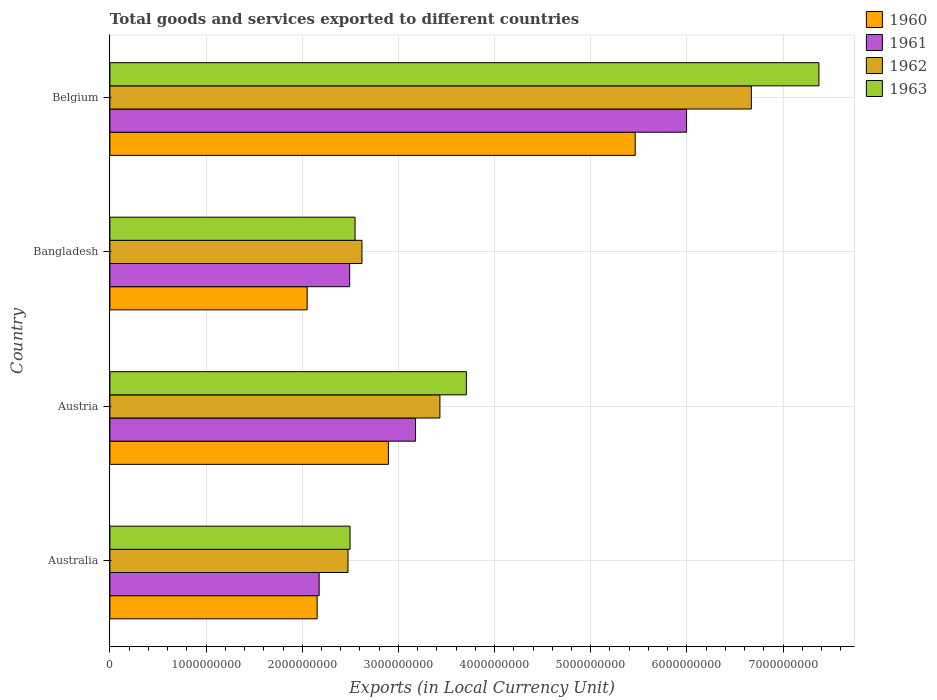How many different coloured bars are there?
Provide a succinct answer. 4. Are the number of bars on each tick of the Y-axis equal?
Your answer should be compact. Yes. How many bars are there on the 3rd tick from the bottom?
Provide a short and direct response. 4. What is the label of the 1st group of bars from the top?
Keep it short and to the point. Belgium. What is the Amount of goods and services exports in 1962 in Australia?
Make the answer very short. 2.48e+09. Across all countries, what is the maximum Amount of goods and services exports in 1963?
Provide a succinct answer. 7.37e+09. Across all countries, what is the minimum Amount of goods and services exports in 1963?
Give a very brief answer. 2.50e+09. In which country was the Amount of goods and services exports in 1961 maximum?
Give a very brief answer. Belgium. What is the total Amount of goods and services exports in 1963 in the graph?
Make the answer very short. 1.61e+1. What is the difference between the Amount of goods and services exports in 1963 in Australia and that in Austria?
Your answer should be compact. -1.21e+09. What is the difference between the Amount of goods and services exports in 1963 in Australia and the Amount of goods and services exports in 1960 in Austria?
Provide a succinct answer. -3.99e+08. What is the average Amount of goods and services exports in 1960 per country?
Make the answer very short. 3.14e+09. What is the difference between the Amount of goods and services exports in 1960 and Amount of goods and services exports in 1963 in Austria?
Your response must be concise. -8.11e+08. What is the ratio of the Amount of goods and services exports in 1962 in Australia to that in Belgium?
Ensure brevity in your answer.  0.37. Is the Amount of goods and services exports in 1960 in Australia less than that in Belgium?
Provide a short and direct response. Yes. What is the difference between the highest and the second highest Amount of goods and services exports in 1961?
Your response must be concise. 2.82e+09. What is the difference between the highest and the lowest Amount of goods and services exports in 1961?
Provide a short and direct response. 3.82e+09. Is the sum of the Amount of goods and services exports in 1962 in Austria and Belgium greater than the maximum Amount of goods and services exports in 1963 across all countries?
Your answer should be compact. Yes. Is it the case that in every country, the sum of the Amount of goods and services exports in 1963 and Amount of goods and services exports in 1961 is greater than the sum of Amount of goods and services exports in 1960 and Amount of goods and services exports in 1962?
Your answer should be compact. No. What does the 2nd bar from the top in Australia represents?
Offer a very short reply. 1962. What does the 4th bar from the bottom in Australia represents?
Your response must be concise. 1963. Is it the case that in every country, the sum of the Amount of goods and services exports in 1961 and Amount of goods and services exports in 1963 is greater than the Amount of goods and services exports in 1960?
Your answer should be very brief. Yes. How many countries are there in the graph?
Make the answer very short. 4. What is the difference between two consecutive major ticks on the X-axis?
Ensure brevity in your answer.  1.00e+09. Does the graph contain grids?
Give a very brief answer. Yes. What is the title of the graph?
Your response must be concise. Total goods and services exported to different countries. Does "2006" appear as one of the legend labels in the graph?
Your response must be concise. No. What is the label or title of the X-axis?
Offer a terse response. Exports (in Local Currency Unit). What is the Exports (in Local Currency Unit) of 1960 in Australia?
Your answer should be very brief. 2.16e+09. What is the Exports (in Local Currency Unit) in 1961 in Australia?
Offer a terse response. 2.18e+09. What is the Exports (in Local Currency Unit) of 1962 in Australia?
Make the answer very short. 2.48e+09. What is the Exports (in Local Currency Unit) of 1963 in Australia?
Provide a succinct answer. 2.50e+09. What is the Exports (in Local Currency Unit) in 1960 in Austria?
Give a very brief answer. 2.90e+09. What is the Exports (in Local Currency Unit) in 1961 in Austria?
Offer a very short reply. 3.18e+09. What is the Exports (in Local Currency Unit) of 1962 in Austria?
Your answer should be very brief. 3.43e+09. What is the Exports (in Local Currency Unit) of 1963 in Austria?
Give a very brief answer. 3.71e+09. What is the Exports (in Local Currency Unit) of 1960 in Bangladesh?
Your answer should be very brief. 2.05e+09. What is the Exports (in Local Currency Unit) of 1961 in Bangladesh?
Make the answer very short. 2.49e+09. What is the Exports (in Local Currency Unit) in 1962 in Bangladesh?
Your answer should be compact. 2.62e+09. What is the Exports (in Local Currency Unit) of 1963 in Bangladesh?
Your answer should be compact. 2.55e+09. What is the Exports (in Local Currency Unit) in 1960 in Belgium?
Make the answer very short. 5.46e+09. What is the Exports (in Local Currency Unit) of 1961 in Belgium?
Make the answer very short. 6.00e+09. What is the Exports (in Local Currency Unit) of 1962 in Belgium?
Make the answer very short. 6.67e+09. What is the Exports (in Local Currency Unit) in 1963 in Belgium?
Offer a very short reply. 7.37e+09. Across all countries, what is the maximum Exports (in Local Currency Unit) in 1960?
Offer a terse response. 5.46e+09. Across all countries, what is the maximum Exports (in Local Currency Unit) in 1961?
Ensure brevity in your answer.  6.00e+09. Across all countries, what is the maximum Exports (in Local Currency Unit) in 1962?
Ensure brevity in your answer.  6.67e+09. Across all countries, what is the maximum Exports (in Local Currency Unit) of 1963?
Keep it short and to the point. 7.37e+09. Across all countries, what is the minimum Exports (in Local Currency Unit) of 1960?
Offer a very short reply. 2.05e+09. Across all countries, what is the minimum Exports (in Local Currency Unit) of 1961?
Ensure brevity in your answer.  2.18e+09. Across all countries, what is the minimum Exports (in Local Currency Unit) in 1962?
Offer a terse response. 2.48e+09. Across all countries, what is the minimum Exports (in Local Currency Unit) in 1963?
Provide a succinct answer. 2.50e+09. What is the total Exports (in Local Currency Unit) in 1960 in the graph?
Your answer should be very brief. 1.26e+1. What is the total Exports (in Local Currency Unit) of 1961 in the graph?
Your answer should be very brief. 1.38e+1. What is the total Exports (in Local Currency Unit) of 1962 in the graph?
Offer a very short reply. 1.52e+1. What is the total Exports (in Local Currency Unit) in 1963 in the graph?
Provide a succinct answer. 1.61e+1. What is the difference between the Exports (in Local Currency Unit) in 1960 in Australia and that in Austria?
Offer a terse response. -7.41e+08. What is the difference between the Exports (in Local Currency Unit) in 1961 in Australia and that in Austria?
Offer a terse response. -1.00e+09. What is the difference between the Exports (in Local Currency Unit) of 1962 in Australia and that in Austria?
Give a very brief answer. -9.56e+08. What is the difference between the Exports (in Local Currency Unit) of 1963 in Australia and that in Austria?
Offer a very short reply. -1.21e+09. What is the difference between the Exports (in Local Currency Unit) in 1960 in Australia and that in Bangladesh?
Ensure brevity in your answer.  1.04e+08. What is the difference between the Exports (in Local Currency Unit) of 1961 in Australia and that in Bangladesh?
Offer a terse response. -3.17e+08. What is the difference between the Exports (in Local Currency Unit) of 1962 in Australia and that in Bangladesh?
Make the answer very short. -1.45e+08. What is the difference between the Exports (in Local Currency Unit) in 1963 in Australia and that in Bangladesh?
Provide a short and direct response. -5.21e+07. What is the difference between the Exports (in Local Currency Unit) of 1960 in Australia and that in Belgium?
Give a very brief answer. -3.31e+09. What is the difference between the Exports (in Local Currency Unit) of 1961 in Australia and that in Belgium?
Give a very brief answer. -3.82e+09. What is the difference between the Exports (in Local Currency Unit) in 1962 in Australia and that in Belgium?
Your response must be concise. -4.19e+09. What is the difference between the Exports (in Local Currency Unit) in 1963 in Australia and that in Belgium?
Keep it short and to the point. -4.88e+09. What is the difference between the Exports (in Local Currency Unit) in 1960 in Austria and that in Bangladesh?
Offer a terse response. 8.45e+08. What is the difference between the Exports (in Local Currency Unit) of 1961 in Austria and that in Bangladesh?
Ensure brevity in your answer.  6.85e+08. What is the difference between the Exports (in Local Currency Unit) of 1962 in Austria and that in Bangladesh?
Provide a succinct answer. 8.10e+08. What is the difference between the Exports (in Local Currency Unit) of 1963 in Austria and that in Bangladesh?
Offer a very short reply. 1.16e+09. What is the difference between the Exports (in Local Currency Unit) in 1960 in Austria and that in Belgium?
Offer a very short reply. -2.57e+09. What is the difference between the Exports (in Local Currency Unit) in 1961 in Austria and that in Belgium?
Offer a very short reply. -2.82e+09. What is the difference between the Exports (in Local Currency Unit) in 1962 in Austria and that in Belgium?
Your answer should be very brief. -3.24e+09. What is the difference between the Exports (in Local Currency Unit) in 1963 in Austria and that in Belgium?
Your answer should be compact. -3.67e+09. What is the difference between the Exports (in Local Currency Unit) in 1960 in Bangladesh and that in Belgium?
Give a very brief answer. -3.41e+09. What is the difference between the Exports (in Local Currency Unit) of 1961 in Bangladesh and that in Belgium?
Your answer should be very brief. -3.50e+09. What is the difference between the Exports (in Local Currency Unit) in 1962 in Bangladesh and that in Belgium?
Give a very brief answer. -4.05e+09. What is the difference between the Exports (in Local Currency Unit) of 1963 in Bangladesh and that in Belgium?
Provide a succinct answer. -4.82e+09. What is the difference between the Exports (in Local Currency Unit) of 1960 in Australia and the Exports (in Local Currency Unit) of 1961 in Austria?
Your answer should be compact. -1.02e+09. What is the difference between the Exports (in Local Currency Unit) in 1960 in Australia and the Exports (in Local Currency Unit) in 1962 in Austria?
Offer a terse response. -1.28e+09. What is the difference between the Exports (in Local Currency Unit) in 1960 in Australia and the Exports (in Local Currency Unit) in 1963 in Austria?
Give a very brief answer. -1.55e+09. What is the difference between the Exports (in Local Currency Unit) in 1961 in Australia and the Exports (in Local Currency Unit) in 1962 in Austria?
Your answer should be compact. -1.26e+09. What is the difference between the Exports (in Local Currency Unit) in 1961 in Australia and the Exports (in Local Currency Unit) in 1963 in Austria?
Provide a succinct answer. -1.53e+09. What is the difference between the Exports (in Local Currency Unit) of 1962 in Australia and the Exports (in Local Currency Unit) of 1963 in Austria?
Keep it short and to the point. -1.23e+09. What is the difference between the Exports (in Local Currency Unit) in 1960 in Australia and the Exports (in Local Currency Unit) in 1961 in Bangladesh?
Ensure brevity in your answer.  -3.38e+08. What is the difference between the Exports (in Local Currency Unit) of 1960 in Australia and the Exports (in Local Currency Unit) of 1962 in Bangladesh?
Your answer should be very brief. -4.66e+08. What is the difference between the Exports (in Local Currency Unit) of 1960 in Australia and the Exports (in Local Currency Unit) of 1963 in Bangladesh?
Ensure brevity in your answer.  -3.94e+08. What is the difference between the Exports (in Local Currency Unit) in 1961 in Australia and the Exports (in Local Currency Unit) in 1962 in Bangladesh?
Keep it short and to the point. -4.45e+08. What is the difference between the Exports (in Local Currency Unit) in 1961 in Australia and the Exports (in Local Currency Unit) in 1963 in Bangladesh?
Give a very brief answer. -3.73e+08. What is the difference between the Exports (in Local Currency Unit) in 1962 in Australia and the Exports (in Local Currency Unit) in 1963 in Bangladesh?
Make the answer very short. -7.31e+07. What is the difference between the Exports (in Local Currency Unit) of 1960 in Australia and the Exports (in Local Currency Unit) of 1961 in Belgium?
Offer a terse response. -3.84e+09. What is the difference between the Exports (in Local Currency Unit) of 1960 in Australia and the Exports (in Local Currency Unit) of 1962 in Belgium?
Ensure brevity in your answer.  -4.52e+09. What is the difference between the Exports (in Local Currency Unit) in 1960 in Australia and the Exports (in Local Currency Unit) in 1963 in Belgium?
Offer a terse response. -5.22e+09. What is the difference between the Exports (in Local Currency Unit) in 1961 in Australia and the Exports (in Local Currency Unit) in 1962 in Belgium?
Your answer should be compact. -4.49e+09. What is the difference between the Exports (in Local Currency Unit) of 1961 in Australia and the Exports (in Local Currency Unit) of 1963 in Belgium?
Make the answer very short. -5.20e+09. What is the difference between the Exports (in Local Currency Unit) of 1962 in Australia and the Exports (in Local Currency Unit) of 1963 in Belgium?
Make the answer very short. -4.90e+09. What is the difference between the Exports (in Local Currency Unit) in 1960 in Austria and the Exports (in Local Currency Unit) in 1961 in Bangladesh?
Your response must be concise. 4.03e+08. What is the difference between the Exports (in Local Currency Unit) in 1960 in Austria and the Exports (in Local Currency Unit) in 1962 in Bangladesh?
Offer a very short reply. 2.75e+08. What is the difference between the Exports (in Local Currency Unit) of 1960 in Austria and the Exports (in Local Currency Unit) of 1963 in Bangladesh?
Offer a terse response. 3.47e+08. What is the difference between the Exports (in Local Currency Unit) of 1961 in Austria and the Exports (in Local Currency Unit) of 1962 in Bangladesh?
Provide a succinct answer. 5.57e+08. What is the difference between the Exports (in Local Currency Unit) of 1961 in Austria and the Exports (in Local Currency Unit) of 1963 in Bangladesh?
Give a very brief answer. 6.29e+08. What is the difference between the Exports (in Local Currency Unit) in 1962 in Austria and the Exports (in Local Currency Unit) in 1963 in Bangladesh?
Offer a terse response. 8.83e+08. What is the difference between the Exports (in Local Currency Unit) in 1960 in Austria and the Exports (in Local Currency Unit) in 1961 in Belgium?
Provide a short and direct response. -3.10e+09. What is the difference between the Exports (in Local Currency Unit) in 1960 in Austria and the Exports (in Local Currency Unit) in 1962 in Belgium?
Your answer should be compact. -3.77e+09. What is the difference between the Exports (in Local Currency Unit) in 1960 in Austria and the Exports (in Local Currency Unit) in 1963 in Belgium?
Give a very brief answer. -4.48e+09. What is the difference between the Exports (in Local Currency Unit) of 1961 in Austria and the Exports (in Local Currency Unit) of 1962 in Belgium?
Offer a very short reply. -3.49e+09. What is the difference between the Exports (in Local Currency Unit) of 1961 in Austria and the Exports (in Local Currency Unit) of 1963 in Belgium?
Offer a terse response. -4.19e+09. What is the difference between the Exports (in Local Currency Unit) in 1962 in Austria and the Exports (in Local Currency Unit) in 1963 in Belgium?
Keep it short and to the point. -3.94e+09. What is the difference between the Exports (in Local Currency Unit) in 1960 in Bangladesh and the Exports (in Local Currency Unit) in 1961 in Belgium?
Offer a very short reply. -3.94e+09. What is the difference between the Exports (in Local Currency Unit) in 1960 in Bangladesh and the Exports (in Local Currency Unit) in 1962 in Belgium?
Give a very brief answer. -4.62e+09. What is the difference between the Exports (in Local Currency Unit) in 1960 in Bangladesh and the Exports (in Local Currency Unit) in 1963 in Belgium?
Give a very brief answer. -5.32e+09. What is the difference between the Exports (in Local Currency Unit) of 1961 in Bangladesh and the Exports (in Local Currency Unit) of 1962 in Belgium?
Provide a short and direct response. -4.18e+09. What is the difference between the Exports (in Local Currency Unit) of 1961 in Bangladesh and the Exports (in Local Currency Unit) of 1963 in Belgium?
Your answer should be very brief. -4.88e+09. What is the difference between the Exports (in Local Currency Unit) of 1962 in Bangladesh and the Exports (in Local Currency Unit) of 1963 in Belgium?
Make the answer very short. -4.75e+09. What is the average Exports (in Local Currency Unit) of 1960 per country?
Offer a very short reply. 3.14e+09. What is the average Exports (in Local Currency Unit) of 1961 per country?
Keep it short and to the point. 3.46e+09. What is the average Exports (in Local Currency Unit) in 1962 per country?
Give a very brief answer. 3.80e+09. What is the average Exports (in Local Currency Unit) in 1963 per country?
Your answer should be very brief. 4.03e+09. What is the difference between the Exports (in Local Currency Unit) in 1960 and Exports (in Local Currency Unit) in 1961 in Australia?
Your answer should be very brief. -2.10e+07. What is the difference between the Exports (in Local Currency Unit) in 1960 and Exports (in Local Currency Unit) in 1962 in Australia?
Your answer should be very brief. -3.21e+08. What is the difference between the Exports (in Local Currency Unit) of 1960 and Exports (in Local Currency Unit) of 1963 in Australia?
Provide a short and direct response. -3.42e+08. What is the difference between the Exports (in Local Currency Unit) in 1961 and Exports (in Local Currency Unit) in 1962 in Australia?
Provide a succinct answer. -3.00e+08. What is the difference between the Exports (in Local Currency Unit) of 1961 and Exports (in Local Currency Unit) of 1963 in Australia?
Keep it short and to the point. -3.21e+08. What is the difference between the Exports (in Local Currency Unit) in 1962 and Exports (in Local Currency Unit) in 1963 in Australia?
Offer a terse response. -2.10e+07. What is the difference between the Exports (in Local Currency Unit) in 1960 and Exports (in Local Currency Unit) in 1961 in Austria?
Give a very brief answer. -2.82e+08. What is the difference between the Exports (in Local Currency Unit) in 1960 and Exports (in Local Currency Unit) in 1962 in Austria?
Offer a terse response. -5.36e+08. What is the difference between the Exports (in Local Currency Unit) of 1960 and Exports (in Local Currency Unit) of 1963 in Austria?
Give a very brief answer. -8.11e+08. What is the difference between the Exports (in Local Currency Unit) in 1961 and Exports (in Local Currency Unit) in 1962 in Austria?
Your answer should be compact. -2.53e+08. What is the difference between the Exports (in Local Currency Unit) in 1961 and Exports (in Local Currency Unit) in 1963 in Austria?
Offer a terse response. -5.29e+08. What is the difference between the Exports (in Local Currency Unit) of 1962 and Exports (in Local Currency Unit) of 1963 in Austria?
Give a very brief answer. -2.75e+08. What is the difference between the Exports (in Local Currency Unit) of 1960 and Exports (in Local Currency Unit) of 1961 in Bangladesh?
Your answer should be very brief. -4.42e+08. What is the difference between the Exports (in Local Currency Unit) of 1960 and Exports (in Local Currency Unit) of 1962 in Bangladesh?
Offer a terse response. -5.70e+08. What is the difference between the Exports (in Local Currency Unit) in 1960 and Exports (in Local Currency Unit) in 1963 in Bangladesh?
Your answer should be very brief. -4.98e+08. What is the difference between the Exports (in Local Currency Unit) in 1961 and Exports (in Local Currency Unit) in 1962 in Bangladesh?
Provide a short and direct response. -1.28e+08. What is the difference between the Exports (in Local Currency Unit) in 1961 and Exports (in Local Currency Unit) in 1963 in Bangladesh?
Offer a very short reply. -5.58e+07. What is the difference between the Exports (in Local Currency Unit) in 1962 and Exports (in Local Currency Unit) in 1963 in Bangladesh?
Your answer should be very brief. 7.21e+07. What is the difference between the Exports (in Local Currency Unit) of 1960 and Exports (in Local Currency Unit) of 1961 in Belgium?
Your response must be concise. -5.34e+08. What is the difference between the Exports (in Local Currency Unit) in 1960 and Exports (in Local Currency Unit) in 1962 in Belgium?
Offer a very short reply. -1.21e+09. What is the difference between the Exports (in Local Currency Unit) of 1960 and Exports (in Local Currency Unit) of 1963 in Belgium?
Provide a succinct answer. -1.91e+09. What is the difference between the Exports (in Local Currency Unit) of 1961 and Exports (in Local Currency Unit) of 1962 in Belgium?
Your answer should be compact. -6.74e+08. What is the difference between the Exports (in Local Currency Unit) in 1961 and Exports (in Local Currency Unit) in 1963 in Belgium?
Your response must be concise. -1.38e+09. What is the difference between the Exports (in Local Currency Unit) in 1962 and Exports (in Local Currency Unit) in 1963 in Belgium?
Provide a short and direct response. -7.02e+08. What is the ratio of the Exports (in Local Currency Unit) in 1960 in Australia to that in Austria?
Give a very brief answer. 0.74. What is the ratio of the Exports (in Local Currency Unit) of 1961 in Australia to that in Austria?
Your answer should be very brief. 0.68. What is the ratio of the Exports (in Local Currency Unit) of 1962 in Australia to that in Austria?
Offer a very short reply. 0.72. What is the ratio of the Exports (in Local Currency Unit) in 1963 in Australia to that in Austria?
Make the answer very short. 0.67. What is the ratio of the Exports (in Local Currency Unit) in 1960 in Australia to that in Bangladesh?
Offer a very short reply. 1.05. What is the ratio of the Exports (in Local Currency Unit) in 1961 in Australia to that in Bangladesh?
Ensure brevity in your answer.  0.87. What is the ratio of the Exports (in Local Currency Unit) of 1962 in Australia to that in Bangladesh?
Provide a short and direct response. 0.94. What is the ratio of the Exports (in Local Currency Unit) in 1963 in Australia to that in Bangladesh?
Your answer should be very brief. 0.98. What is the ratio of the Exports (in Local Currency Unit) in 1960 in Australia to that in Belgium?
Make the answer very short. 0.39. What is the ratio of the Exports (in Local Currency Unit) in 1961 in Australia to that in Belgium?
Your answer should be very brief. 0.36. What is the ratio of the Exports (in Local Currency Unit) in 1962 in Australia to that in Belgium?
Make the answer very short. 0.37. What is the ratio of the Exports (in Local Currency Unit) in 1963 in Australia to that in Belgium?
Your answer should be compact. 0.34. What is the ratio of the Exports (in Local Currency Unit) of 1960 in Austria to that in Bangladesh?
Your response must be concise. 1.41. What is the ratio of the Exports (in Local Currency Unit) in 1961 in Austria to that in Bangladesh?
Make the answer very short. 1.27. What is the ratio of the Exports (in Local Currency Unit) of 1962 in Austria to that in Bangladesh?
Provide a succinct answer. 1.31. What is the ratio of the Exports (in Local Currency Unit) of 1963 in Austria to that in Bangladesh?
Your answer should be compact. 1.45. What is the ratio of the Exports (in Local Currency Unit) of 1960 in Austria to that in Belgium?
Keep it short and to the point. 0.53. What is the ratio of the Exports (in Local Currency Unit) in 1961 in Austria to that in Belgium?
Offer a very short reply. 0.53. What is the ratio of the Exports (in Local Currency Unit) of 1962 in Austria to that in Belgium?
Provide a short and direct response. 0.51. What is the ratio of the Exports (in Local Currency Unit) of 1963 in Austria to that in Belgium?
Ensure brevity in your answer.  0.5. What is the ratio of the Exports (in Local Currency Unit) of 1960 in Bangladesh to that in Belgium?
Ensure brevity in your answer.  0.38. What is the ratio of the Exports (in Local Currency Unit) in 1961 in Bangladesh to that in Belgium?
Provide a short and direct response. 0.42. What is the ratio of the Exports (in Local Currency Unit) of 1962 in Bangladesh to that in Belgium?
Give a very brief answer. 0.39. What is the ratio of the Exports (in Local Currency Unit) in 1963 in Bangladesh to that in Belgium?
Make the answer very short. 0.35. What is the difference between the highest and the second highest Exports (in Local Currency Unit) of 1960?
Provide a short and direct response. 2.57e+09. What is the difference between the highest and the second highest Exports (in Local Currency Unit) of 1961?
Give a very brief answer. 2.82e+09. What is the difference between the highest and the second highest Exports (in Local Currency Unit) in 1962?
Offer a very short reply. 3.24e+09. What is the difference between the highest and the second highest Exports (in Local Currency Unit) of 1963?
Offer a terse response. 3.67e+09. What is the difference between the highest and the lowest Exports (in Local Currency Unit) in 1960?
Make the answer very short. 3.41e+09. What is the difference between the highest and the lowest Exports (in Local Currency Unit) in 1961?
Your answer should be very brief. 3.82e+09. What is the difference between the highest and the lowest Exports (in Local Currency Unit) in 1962?
Make the answer very short. 4.19e+09. What is the difference between the highest and the lowest Exports (in Local Currency Unit) in 1963?
Offer a very short reply. 4.88e+09. 